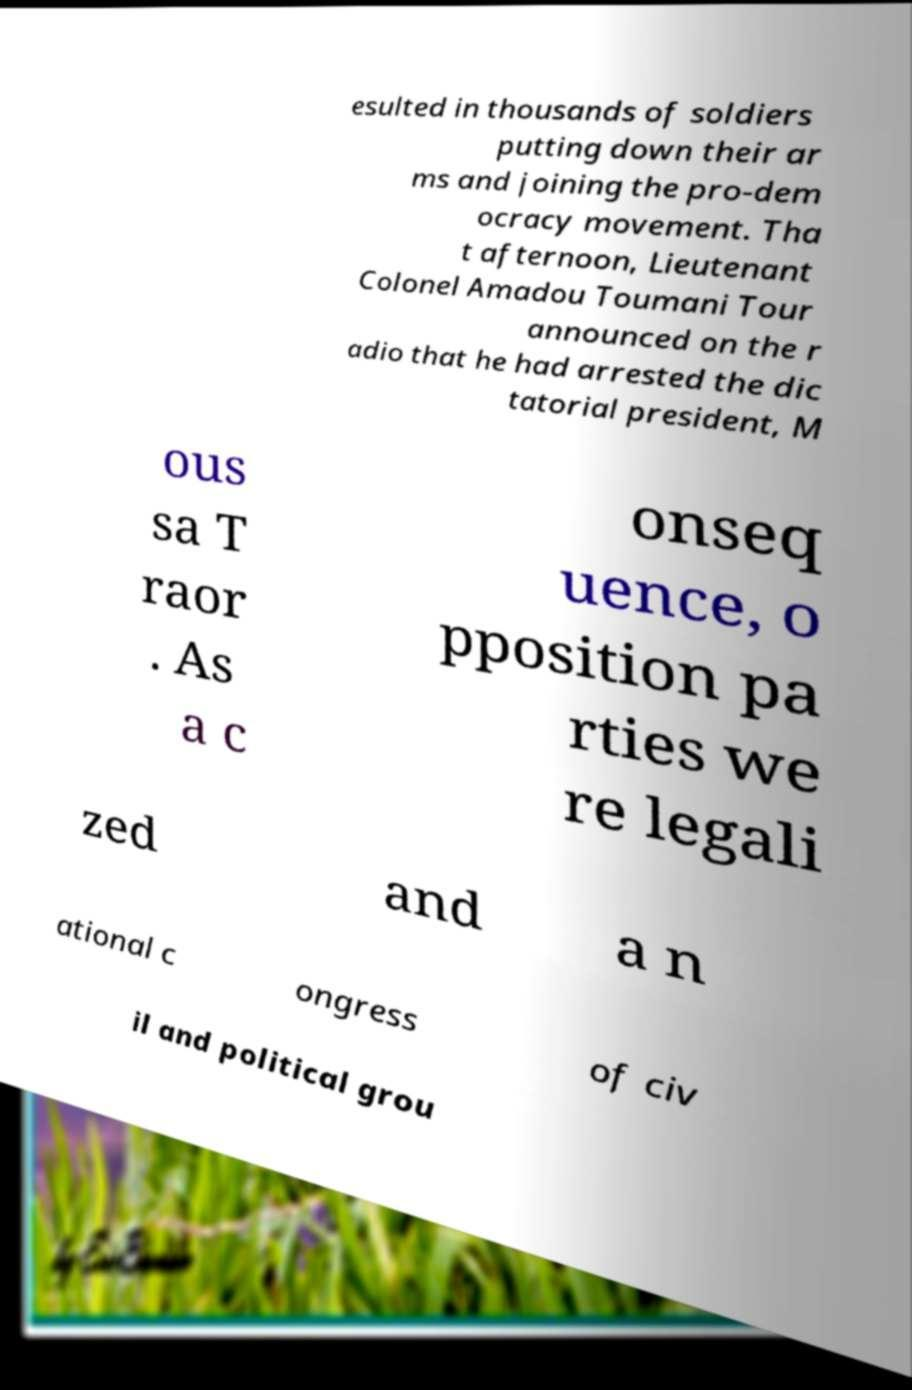Can you accurately transcribe the text from the provided image for me? esulted in thousands of soldiers putting down their ar ms and joining the pro-dem ocracy movement. Tha t afternoon, Lieutenant Colonel Amadou Toumani Tour announced on the r adio that he had arrested the dic tatorial president, M ous sa T raor . As a c onseq uence, o pposition pa rties we re legali zed and a n ational c ongress of civ il and political grou 